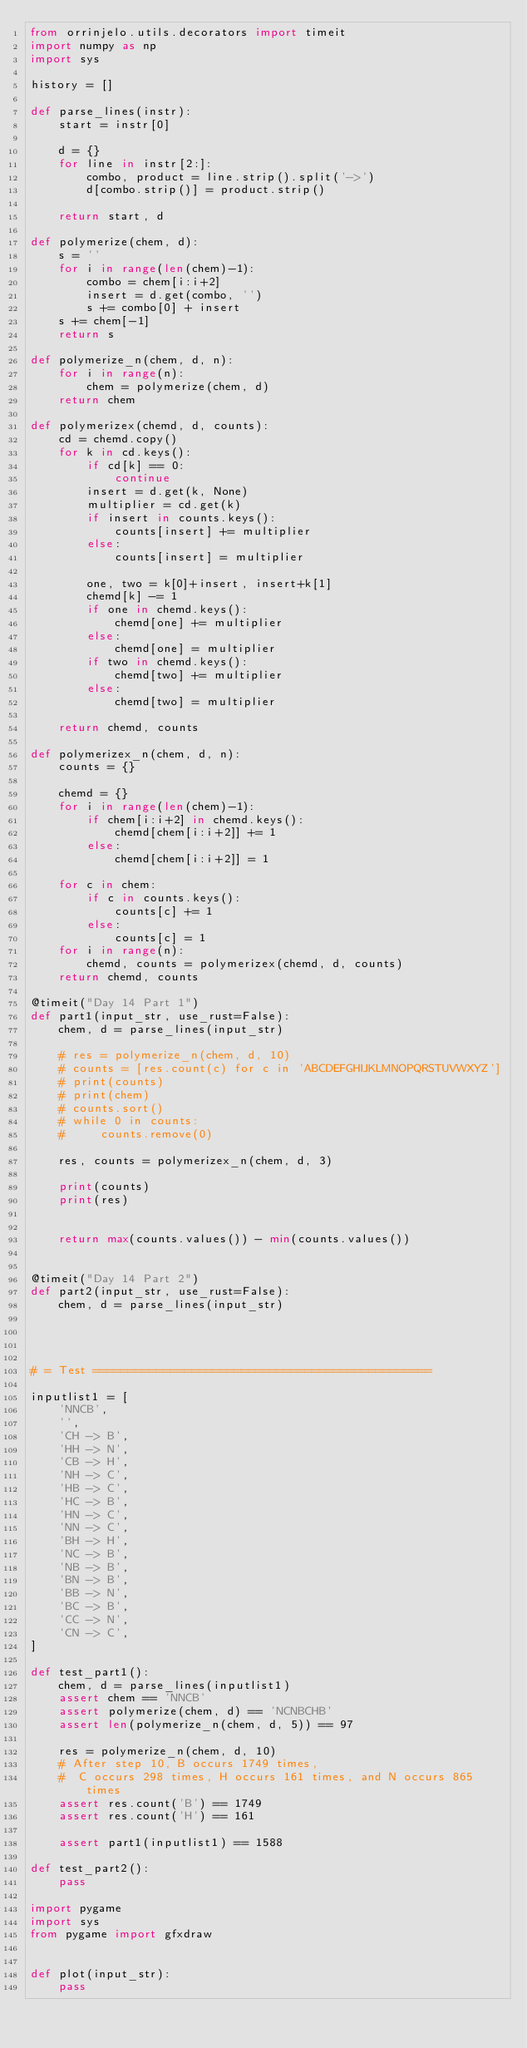<code> <loc_0><loc_0><loc_500><loc_500><_Python_>from orrinjelo.utils.decorators import timeit
import numpy as np
import sys

history = []

def parse_lines(instr):
    start = instr[0]

    d = {}
    for line in instr[2:]:
        combo, product = line.strip().split('->')
        d[combo.strip()] = product.strip()

    return start, d

def polymerize(chem, d):
    s = ''
    for i in range(len(chem)-1):
        combo = chem[i:i+2]
        insert = d.get(combo, '')
        s += combo[0] + insert
    s += chem[-1]
    return s

def polymerize_n(chem, d, n):
    for i in range(n):
        chem = polymerize(chem, d)
    return chem

def polymerizex(chemd, d, counts):
    cd = chemd.copy()
    for k in cd.keys():
        if cd[k] == 0:
            continue
        insert = d.get(k, None)
        multiplier = cd.get(k)
        if insert in counts.keys():
            counts[insert] += multiplier
        else:
            counts[insert] = multiplier

        one, two = k[0]+insert, insert+k[1]
        chemd[k] -= 1
        if one in chemd.keys():
            chemd[one] += multiplier
        else:
            chemd[one] = multiplier
        if two in chemd.keys():
            chemd[two] += multiplier
        else:
            chemd[two] = multiplier

    return chemd, counts

def polymerizex_n(chem, d, n):
    counts = {}

    chemd = {}
    for i in range(len(chem)-1):
        if chem[i:i+2] in chemd.keys():
            chemd[chem[i:i+2]] += 1
        else:
            chemd[chem[i:i+2]] = 1

    for c in chem:
        if c in counts.keys():
            counts[c] += 1
        else:
            counts[c] = 1
    for i in range(n):
        chemd, counts = polymerizex(chemd, d, counts)
    return chemd, counts

@timeit("Day 14 Part 1")
def part1(input_str, use_rust=False):
    chem, d = parse_lines(input_str)

    # res = polymerize_n(chem, d, 10)
    # counts = [res.count(c) for c in 'ABCDEFGHIJKLMNOPQRSTUVWXYZ']
    # print(counts)
    # print(chem)
    # counts.sort()
    # while 0 in counts:
    #     counts.remove(0)

    res, counts = polymerizex_n(chem, d, 3)

    print(counts)
    print(res)


    return max(counts.values()) - min(counts.values())


@timeit("Day 14 Part 2")
def part2(input_str, use_rust=False):
    chem, d = parse_lines(input_str)




# = Test ================================================

inputlist1 = [
    'NNCB',
    '',
    'CH -> B',
    'HH -> N',
    'CB -> H',
    'NH -> C',
    'HB -> C',
    'HC -> B',
    'HN -> C',
    'NN -> C',
    'BH -> H',
    'NC -> B',
    'NB -> B',
    'BN -> B',
    'BB -> N',
    'BC -> B',
    'CC -> N',
    'CN -> C',
]

def test_part1():
    chem, d = parse_lines(inputlist1)
    assert chem == 'NNCB'
    assert polymerize(chem, d) == 'NCNBCHB'
    assert len(polymerize_n(chem, d, 5)) == 97

    res = polymerize_n(chem, d, 10)
    # After step 10, B occurs 1749 times, 
    #  C occurs 298 times, H occurs 161 times, and N occurs 865 times
    assert res.count('B') == 1749
    assert res.count('H') == 161

    assert part1(inputlist1) == 1588

def test_part2():
    pass

import pygame
import sys
from pygame import gfxdraw


def plot(input_str):
    pass</code> 